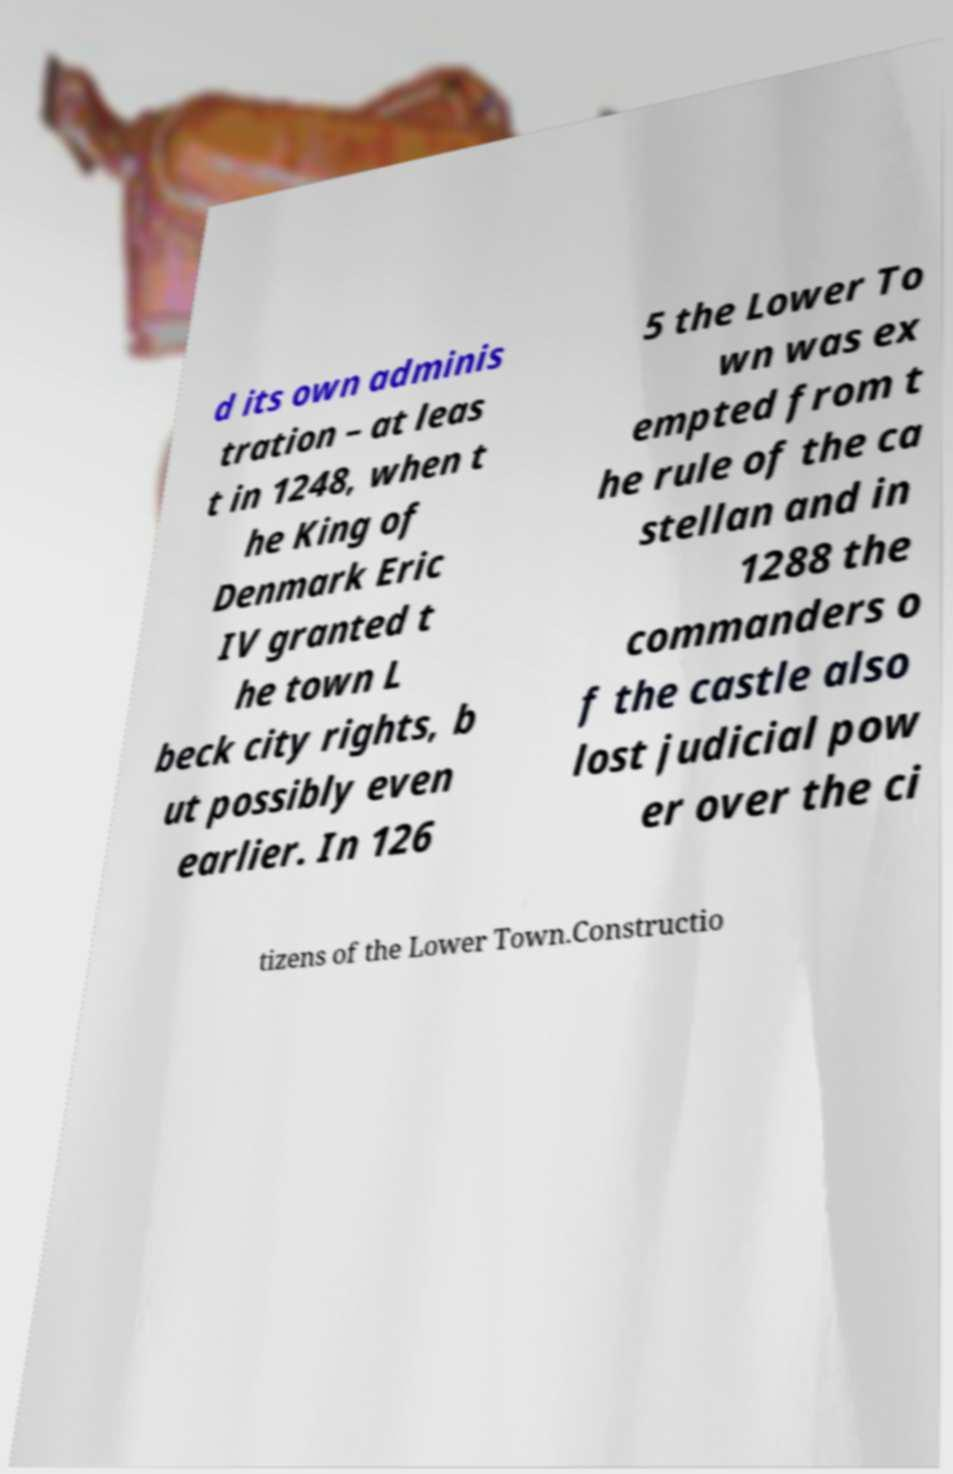What messages or text are displayed in this image? I need them in a readable, typed format. d its own adminis tration – at leas t in 1248, when t he King of Denmark Eric IV granted t he town L beck city rights, b ut possibly even earlier. In 126 5 the Lower To wn was ex empted from t he rule of the ca stellan and in 1288 the commanders o f the castle also lost judicial pow er over the ci tizens of the Lower Town.Constructio 